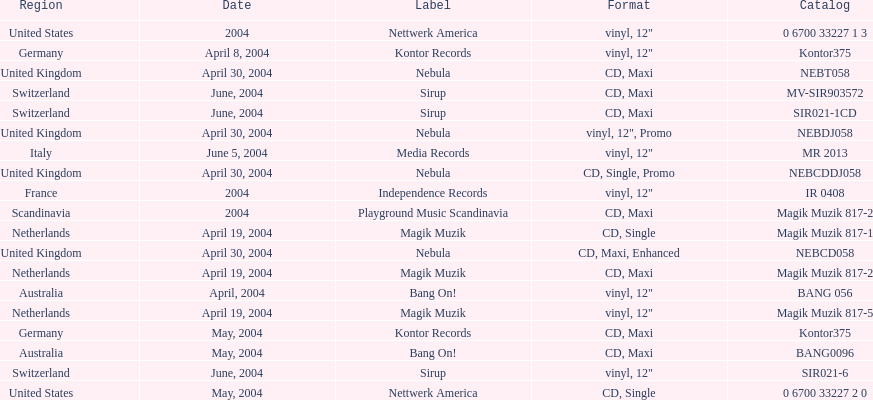What region is listed at the top? Netherlands. Could you help me parse every detail presented in this table? {'header': ['Region', 'Date', 'Label', 'Format', 'Catalog'], 'rows': [['United States', '2004', 'Nettwerk America', 'vinyl, 12"', '0 6700 33227 1 3'], ['Germany', 'April 8, 2004', 'Kontor Records', 'vinyl, 12"', 'Kontor375'], ['United Kingdom', 'April 30, 2004', 'Nebula', 'CD, Maxi', 'NEBT058'], ['Switzerland', 'June, 2004', 'Sirup', 'CD, Maxi', 'MV-SIR903572'], ['Switzerland', 'June, 2004', 'Sirup', 'CD, Maxi', 'SIR021-1CD'], ['United Kingdom', 'April 30, 2004', 'Nebula', 'vinyl, 12", Promo', 'NEBDJ058'], ['Italy', 'June 5, 2004', 'Media Records', 'vinyl, 12"', 'MR 2013'], ['United Kingdom', 'April 30, 2004', 'Nebula', 'CD, Single, Promo', 'NEBCDDJ058'], ['France', '2004', 'Independence Records', 'vinyl, 12"', 'IR 0408'], ['Scandinavia', '2004', 'Playground Music Scandinavia', 'CD, Maxi', 'Magik Muzik 817-2'], ['Netherlands', 'April 19, 2004', 'Magik Muzik', 'CD, Single', 'Magik Muzik 817-1'], ['United Kingdom', 'April 30, 2004', 'Nebula', 'CD, Maxi, Enhanced', 'NEBCD058'], ['Netherlands', 'April 19, 2004', 'Magik Muzik', 'CD, Maxi', 'Magik Muzik 817-2'], ['Australia', 'April, 2004', 'Bang On!', 'vinyl, 12"', 'BANG 056'], ['Netherlands', 'April 19, 2004', 'Magik Muzik', 'vinyl, 12"', 'Magik Muzik 817-5'], ['Germany', 'May, 2004', 'Kontor Records', 'CD, Maxi', 'Kontor375'], ['Australia', 'May, 2004', 'Bang On!', 'CD, Maxi', 'BANG0096'], ['Switzerland', 'June, 2004', 'Sirup', 'vinyl, 12"', 'SIR021-6'], ['United States', 'May, 2004', 'Nettwerk America', 'CD, Single', '0 6700 33227 2 0']]} 